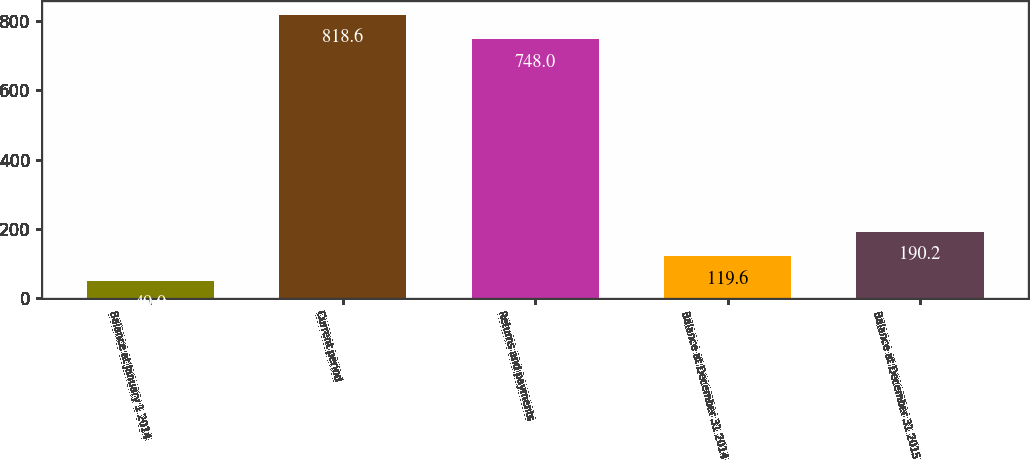Convert chart. <chart><loc_0><loc_0><loc_500><loc_500><bar_chart><fcel>Balance at January 1 2014<fcel>Current period<fcel>Returns and payments<fcel>Balance at December 31 2014<fcel>Balance at December 31 2015<nl><fcel>49<fcel>818.6<fcel>748<fcel>119.6<fcel>190.2<nl></chart> 